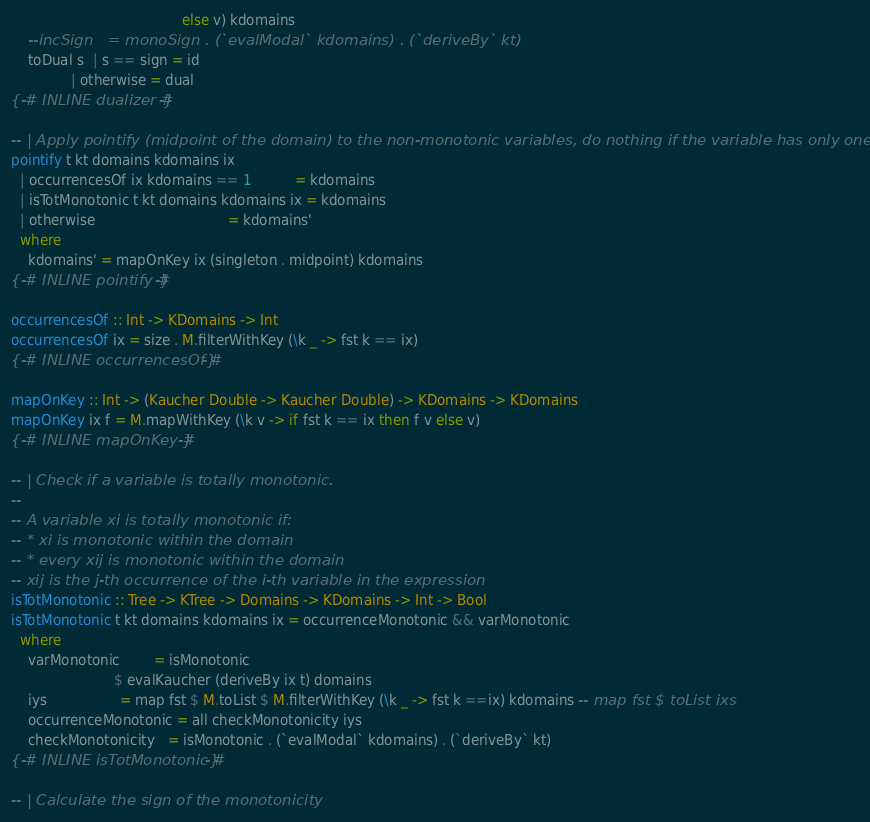Convert code to text. <code><loc_0><loc_0><loc_500><loc_500><_Haskell_>                                        else v) kdomains
    --incSign   = monoSign . (`evalModal` kdomains) . (`deriveBy` kt)
    toDual s  | s == sign = id
              | otherwise = dual
{-# INLINE dualizer #-}

-- | Apply pointify (midpoint of the domain) to the non-monotonic variables, do nothing if the variable has only one incidence.
pointify t kt domains kdomains ix
  | occurrencesOf ix kdomains == 1          = kdomains
  | isTotMonotonic t kt domains kdomains ix = kdomains
  | otherwise                               = kdomains'
  where
    kdomains' = mapOnKey ix (singleton . midpoint) kdomains
{-# INLINE pointify #-}

occurrencesOf :: Int -> KDomains -> Int
occurrencesOf ix = size . M.filterWithKey (\k _ -> fst k == ix)
{-# INLINE occurrencesOf #-}

mapOnKey :: Int -> (Kaucher Double -> Kaucher Double) -> KDomains -> KDomains
mapOnKey ix f = M.mapWithKey (\k v -> if fst k == ix then f v else v)
{-# INLINE mapOnKey #-}

-- | Check if a variable is totally monotonic.
--
-- A variable xi is totally monotonic if:
-- * xi is monotonic within the domain
-- * every xij is monotonic within the domain
-- xij is the j-th occurrence of the i-th variable in the expression
isTotMonotonic :: Tree -> KTree -> Domains -> KDomains -> Int -> Bool
isTotMonotonic t kt domains kdomains ix = occurrenceMonotonic && varMonotonic
  where
    varMonotonic        = isMonotonic
                        $ evalKaucher (deriveBy ix t) domains
    iys                 = map fst $ M.toList $ M.filterWithKey (\k _ -> fst k ==ix) kdomains -- map fst $ toList ixs
    occurrenceMonotonic = all checkMonotonicity iys
    checkMonotonicity   = isMonotonic . (`evalModal` kdomains) . (`deriveBy` kt)
{-# INLINE isTotMonotonic #-}

-- | Calculate the sign of the monotonicity</code> 